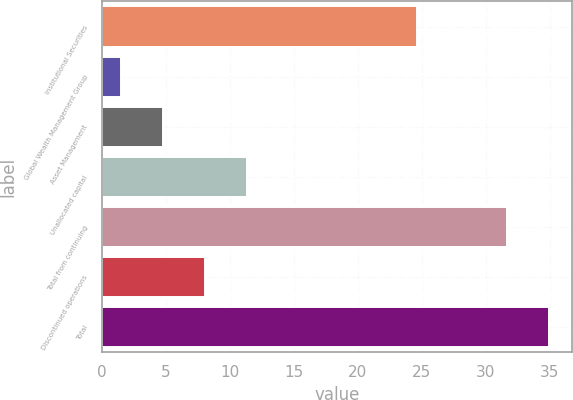<chart> <loc_0><loc_0><loc_500><loc_500><bar_chart><fcel>Institutional Securities<fcel>Global Wealth Management Group<fcel>Asset Management<fcel>Unallocated capital<fcel>Total from continuing<fcel>Discontinued operations<fcel>Total<nl><fcel>24.6<fcel>1.5<fcel>4.79<fcel>11.37<fcel>31.7<fcel>8.08<fcel>34.99<nl></chart> 